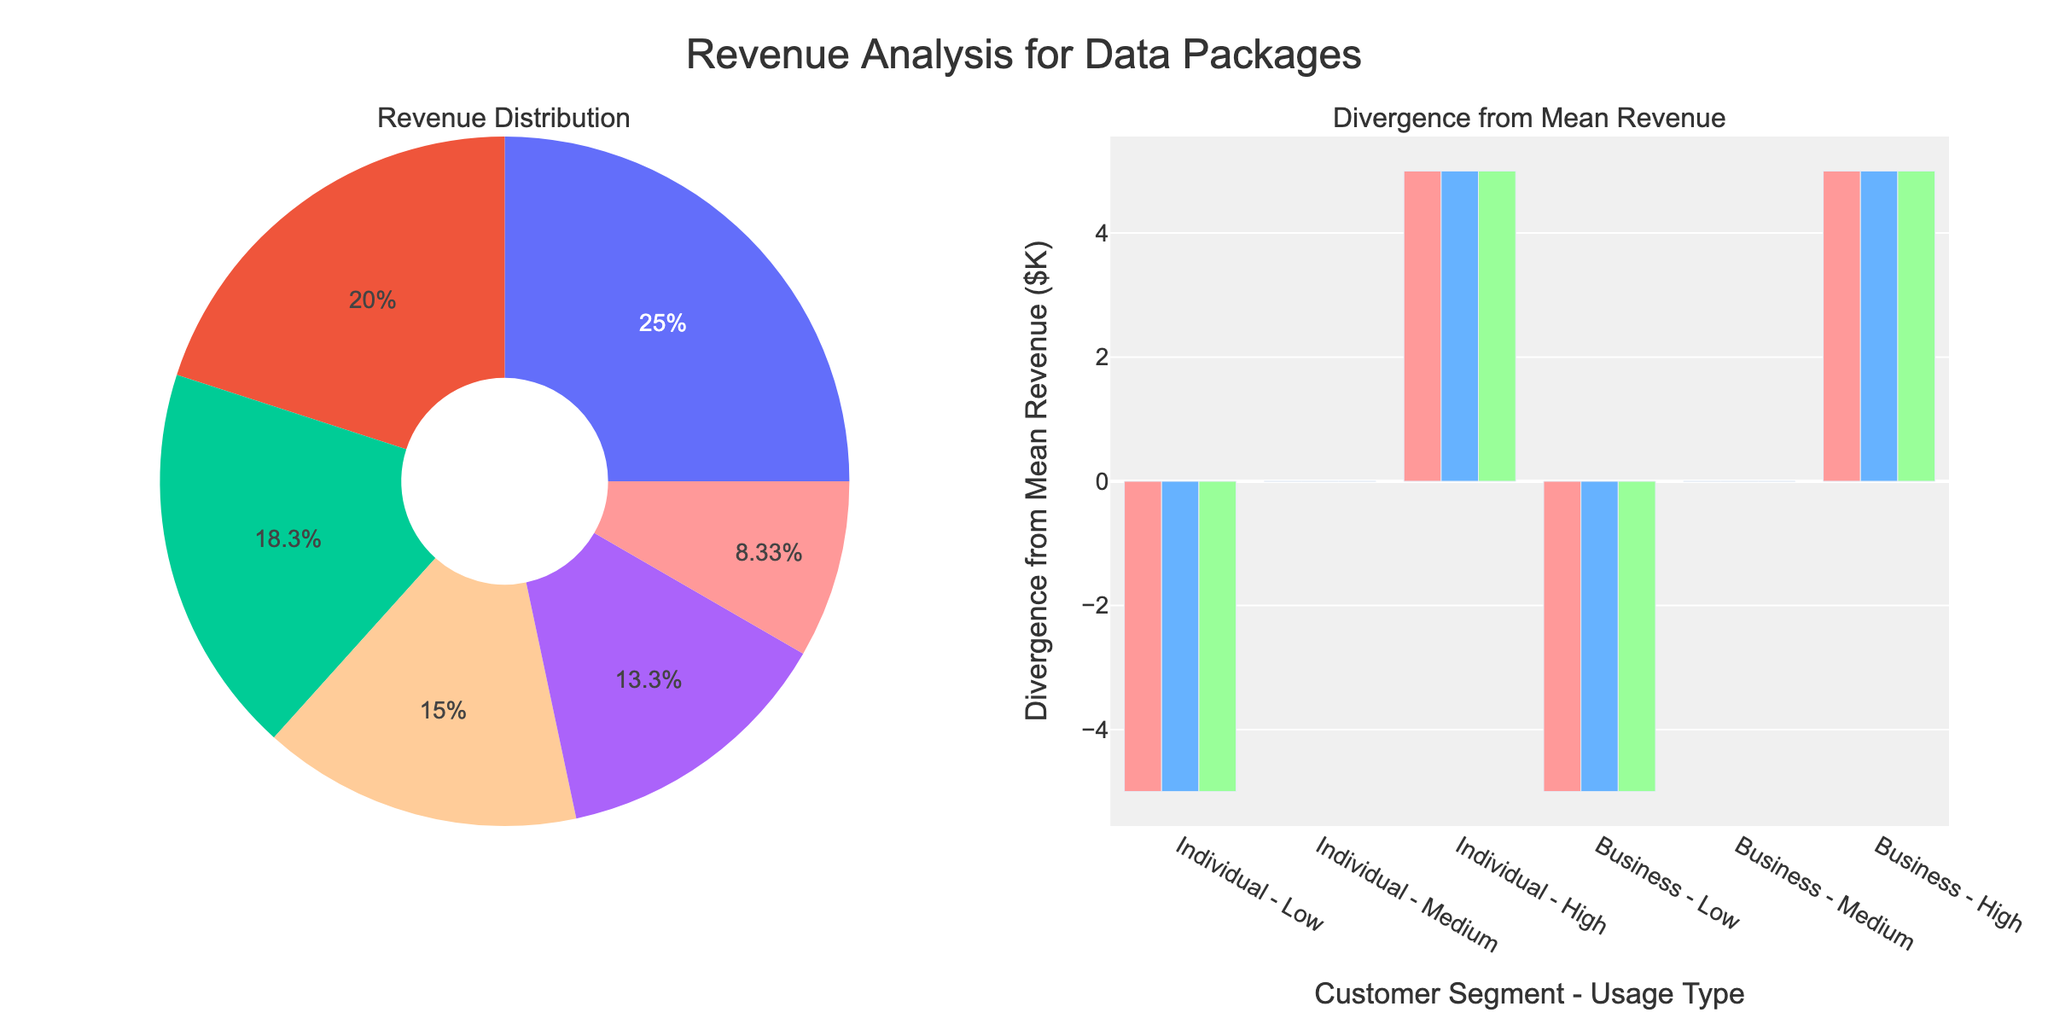What is the total revenue for the Business segment in the Premium tier? The Business segment in the Premium tier has three usage types: Low, Medium, and High, with respective revenues of $70K, $75K, and $80K. Adding these gives 70 + 75 + 80 = $225K.
Answer: $225K Which combined segment and usage type has the highest positive divergence from mean revenue in the Standard tier? We look at the bars in the Standard tier for the segment with the highest positive divergence. The segment with the highest positive divergence is the Business - High Usage with the largest bar above the zero line.
Answer: Business - High How does the revenue for the Individual segment in the Basic tier compare with the Business segment in the Basic tier? Sum the revenues for the Individual segment in Basic tier (20 + 25 + 30 = $75K) and compare it with the sum of the Business segment in Basic tier (40 + 45 + 50 = $135K). $75K is less than $135K.
Answer: Less Which tier shows the least divergence in mean revenue for the Business segment? Observe the Vertical position of the Business segment bars across all tiers. We notice that the bars in the Basic tier seem to diverge less from their means compared to Standard and Premium tiers.
Answer: Basic What is the average revenue for the Medium Usage type across all Pricing Tiers? Sum the revenues for Medium Usage in all Pricing Tiers: 25 (Basic Individual) + 45 (Basic Business) + 40 (Standard Individual) + 60 (Standard Business) + 55 (Premium Individual) + 75 (Premium Business). The total is 300. There are 6 values, so the average is 300/6 = $50K
Answer: $50K Does the Individual or Business segment contribute more to the revenue in the Standard tier? Sum all the revenues for the Individual and Business segments in the Standard tier. Individual has 35 + 40 + 45 = $120K, and Business has 55 + 60 + 65 = $180K. The Business segment contributes more.
Answer: Business What is the divergence from mean revenue for the High Usage type in the Premium Individual segment? First, calculate the mean revenue for Premium Individual segment: (50 + 55 + 60) / 3 = $55K. The revenue for High Usage is $60K. The divergence is 60 - 55 = $5K.
Answer: $5K What is the difference in total revenue between Individual and Business segments in the Standard tier? Calculate the total revenue for Individual (35 + 40 + 45 = $120K) and Business (55 + 60 + 65 = $180K). The difference is 180 - 120 = $60K.
Answer: $60K Which segment and usage type has the lowest negative divergence from the mean revenue in the Basic tier? Examine the bars in the Basic tier for the lowest negative divergence from the mean. The segment with the lowest negative divergence is Individual - Low Usage with the shortest bar below the zero line.
Answer: Individual - Low Which pricing tier generates the highest total revenue for High Usage type? Sum the revenues for High Usage type in each tier: Basic (30 + 50 = $80K), Standard (45 + 65 = $110K), Premium (60 + 80 = $140K). The Premium tier generates the highest total revenue of $140K.
Answer: Premium 